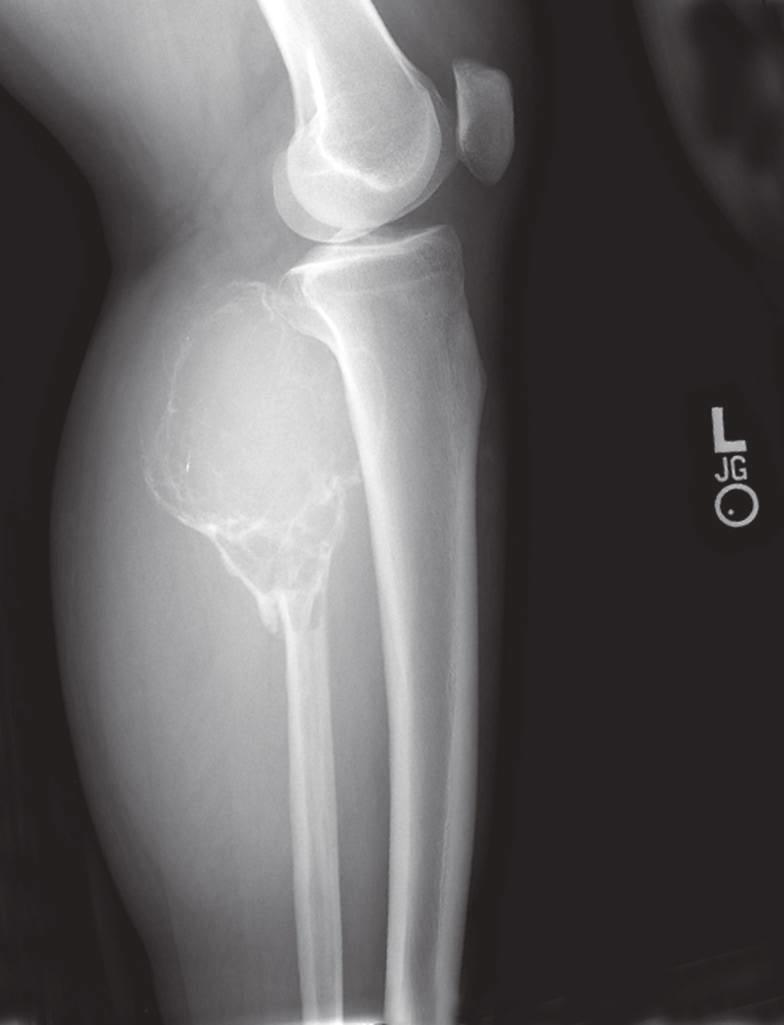s giant cell tumor of the proximal fibula predominantly lytic, expansile with destruction of the cortex?
Answer the question using a single word or phrase. Yes 